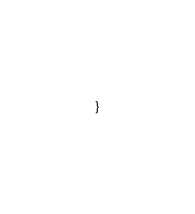<code> <loc_0><loc_0><loc_500><loc_500><_Scala_>

}
</code> 